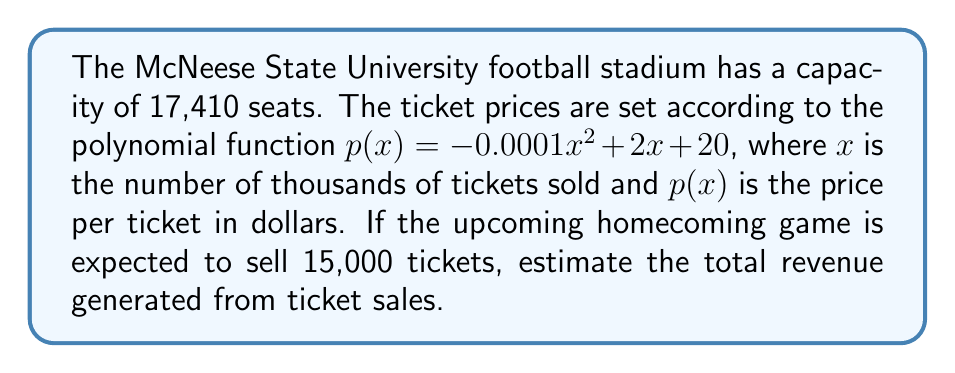Teach me how to tackle this problem. To solve this problem, we need to follow these steps:

1) First, we need to find the price per ticket when 15,000 tickets are sold. We'll use the given function $p(x) = -0.0001x^2 + 2x + 20$.

2) Since $x$ is in thousands, for 15,000 tickets, we use $x = 15$.

3) Let's calculate $p(15)$:

   $$\begin{align}
   p(15) &= -0.0001(15)^2 + 2(15) + 20 \\
         &= -0.0001(225) + 30 + 20 \\
         &= -0.0225 + 50 \\
         &= 49.9775
   \end{align}$$

4) So, each ticket will cost approximately $49.98 when 15,000 tickets are sold.

5) To calculate the total revenue, we multiply the number of tickets by the price per ticket:

   $$\text{Revenue} = 15,000 \times 49.9775 = 749,662.50$$

Therefore, the estimated revenue from selling 15,000 tickets is $749,662.50.
Answer: $749,662.50 